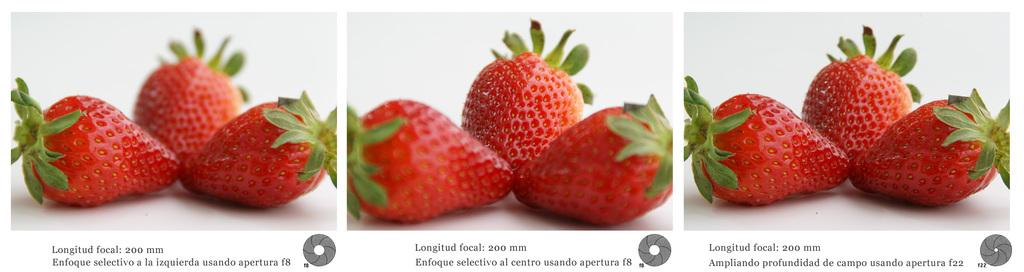What type of fruit is present in the image? There are strawberries in the image. What color is the surface on which the strawberries are placed? The strawberries are on a white color surface. Is there any text or writing in the image? Yes, there is text or writing in the image. How is the image composed? The image is a collage. What type of prison can be seen in the image? There is no prison present in the image; it features strawberries on a white surface with text or writing and is a collage. 